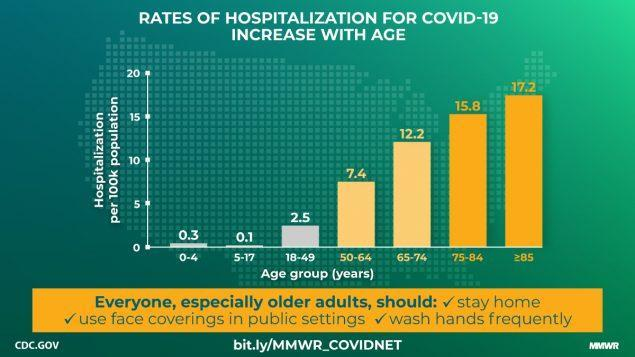for which age group has the hospitalization rate been the lowest
Answer the question with a short phrase. 5-17 for which age group has the hospitalization rate been the second higest 75-84 What is the total count of people hospitals per 100K in the age group of above 75 33 